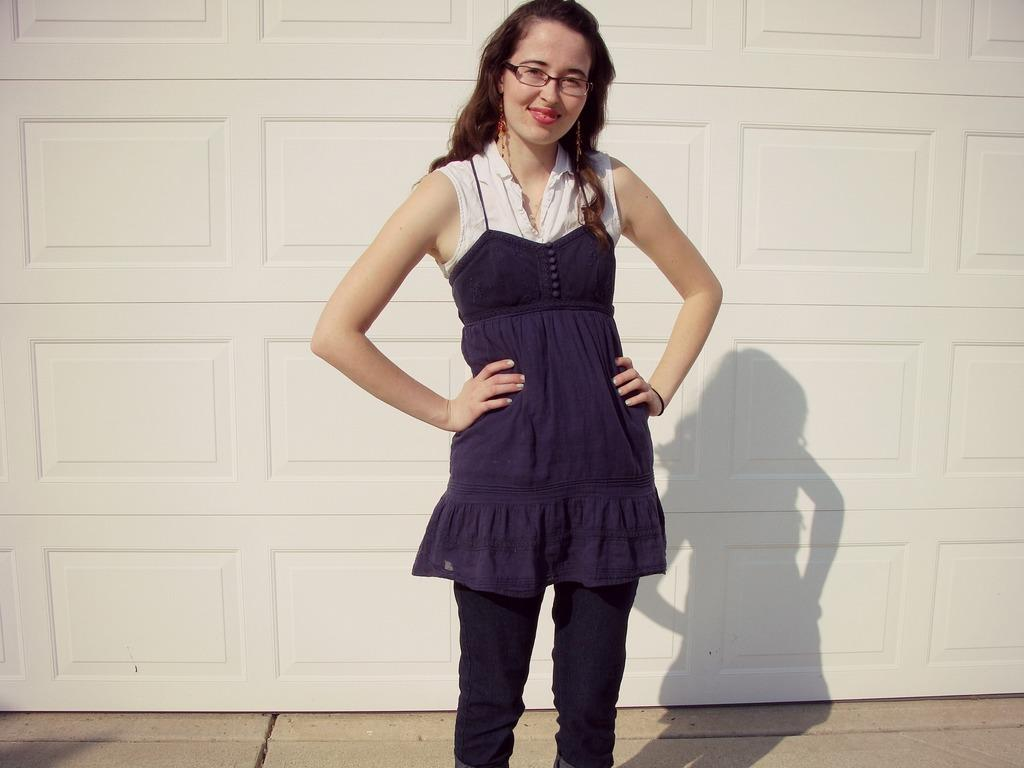Who is present in the image? There is a woman in the image. What is the woman's facial expression? The woman is smiling. What accessory is the woman wearing? The woman is wearing spectacles. What type of stitch is the woman using to sew in the image? There is no stitch or sewing activity present in the image. 